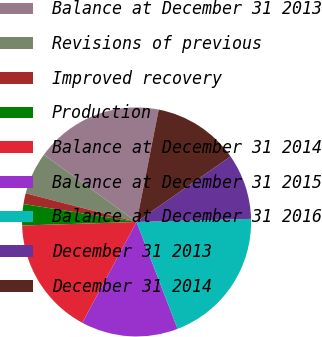Convert chart. <chart><loc_0><loc_0><loc_500><loc_500><pie_chart><fcel>Balance at December 31 2013<fcel>Revisions of previous<fcel>Improved recovery<fcel>Production<fcel>Balance at December 31 2014<fcel>Balance at December 31 2015<fcel>Balance at December 31 2016<fcel>December 31 2013<fcel>December 31 2014<nl><fcel>18.12%<fcel>5.95%<fcel>1.52%<fcel>3.0%<fcel>16.64%<fcel>13.69%<fcel>19.6%<fcel>9.26%<fcel>12.21%<nl></chart> 